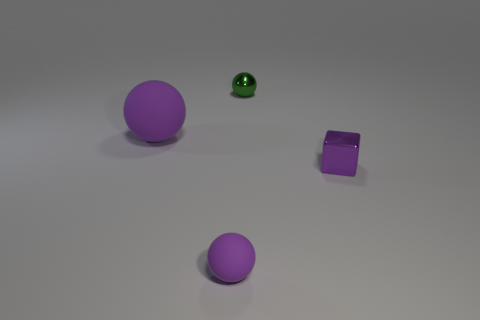What number of purple rubber objects are in front of the green metal ball?
Offer a very short reply. 2. Does the small metallic sphere have the same color as the big rubber object?
Provide a succinct answer. No. What number of tiny balls are the same color as the tiny metallic cube?
Give a very brief answer. 1. Is the number of yellow metal blocks greater than the number of small purple shiny cubes?
Your answer should be compact. No. There is a ball that is on the left side of the tiny green thing and behind the small rubber thing; what size is it?
Ensure brevity in your answer.  Large. Is the material of the object that is on the right side of the tiny green metallic object the same as the small purple object that is in front of the tiny purple shiny thing?
Offer a terse response. No. What shape is the purple metal thing that is the same size as the green sphere?
Provide a short and direct response. Cube. Are there fewer large blue cylinders than tiny purple metal cubes?
Give a very brief answer. Yes. Is there a small purple matte object that is left of the purple matte thing that is in front of the small metallic block?
Provide a short and direct response. No. There is a matte ball that is on the left side of the tiny ball that is on the left side of the green metallic thing; are there any big purple spheres in front of it?
Offer a very short reply. No. 